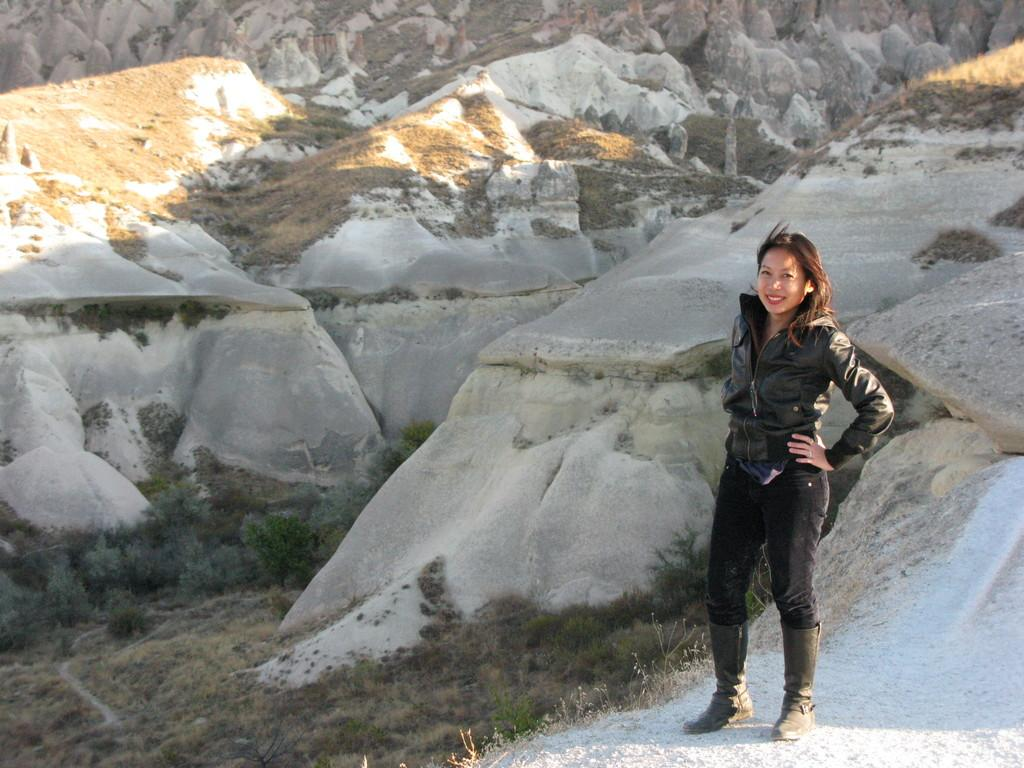What type of natural elements can be seen in the image? There are rocks and grass in the image. Who is present in the image? There is a woman in the image. What type of list can be seen in the woman's hand in the image? There is no list visible in the woman's hand in the image. What type of pickle is present in the image? There is no pickle present in the image. 